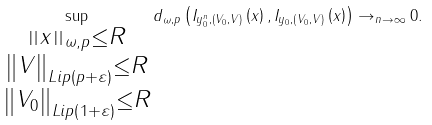<formula> <loc_0><loc_0><loc_500><loc_500>\sup _ { \substack { _ { \substack { \left \| x \right \| _ { \omega , p } \leq R \\ \left \| V \right \| _ { L i p \left ( p + \varepsilon \right ) } \leq R } } \\ \left \| V _ { 0 } \right \| _ { L i p \left ( 1 + \varepsilon \right ) } \leq R } } d _ { \omega , p } \left ( I _ { y _ { 0 } ^ { n } , \left ( V _ { 0 } , V \right ) } \left ( x \right ) , I _ { y _ { 0 } , \left ( V _ { 0 } , V \right ) } \left ( x \right ) \right ) \rightarrow _ { n \rightarrow \infty } 0 .</formula> 